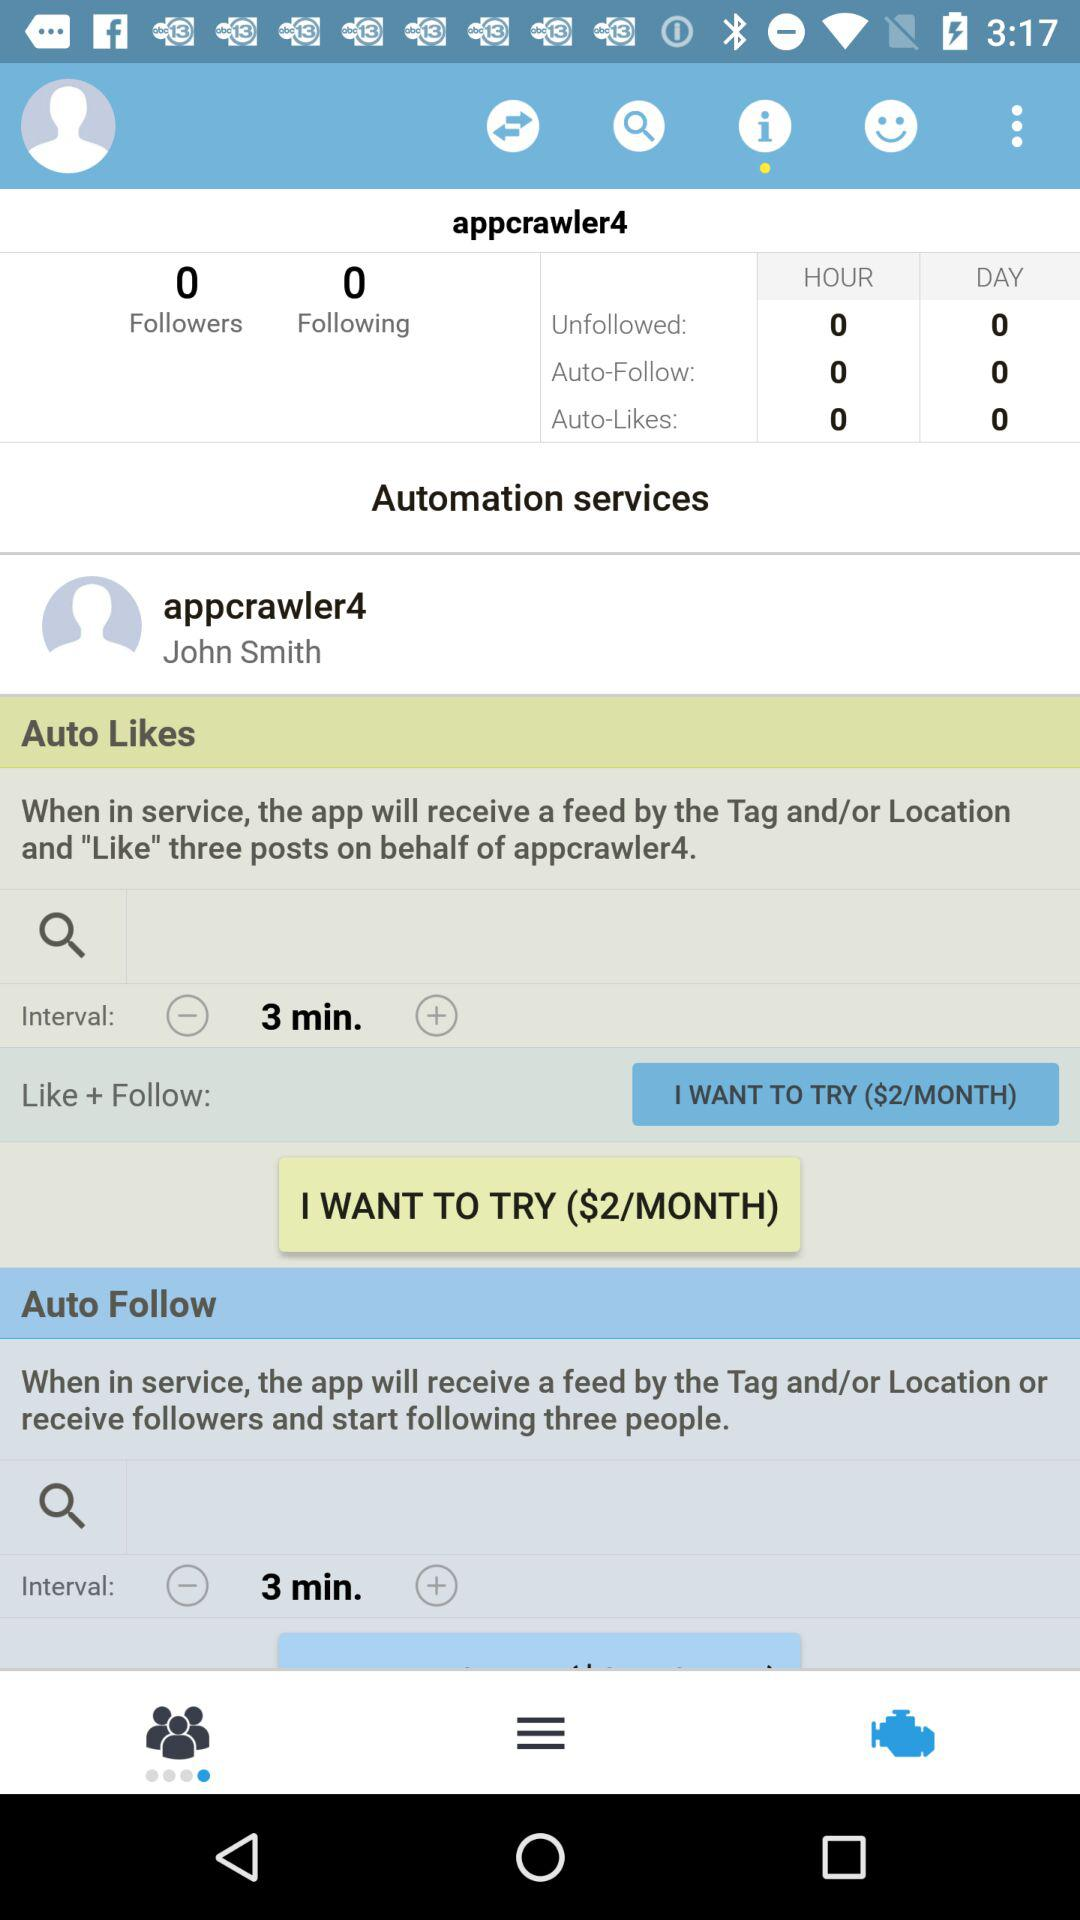What is the minimum amount of time between likes?
Answer the question using a single word or phrase. 3 minutes 